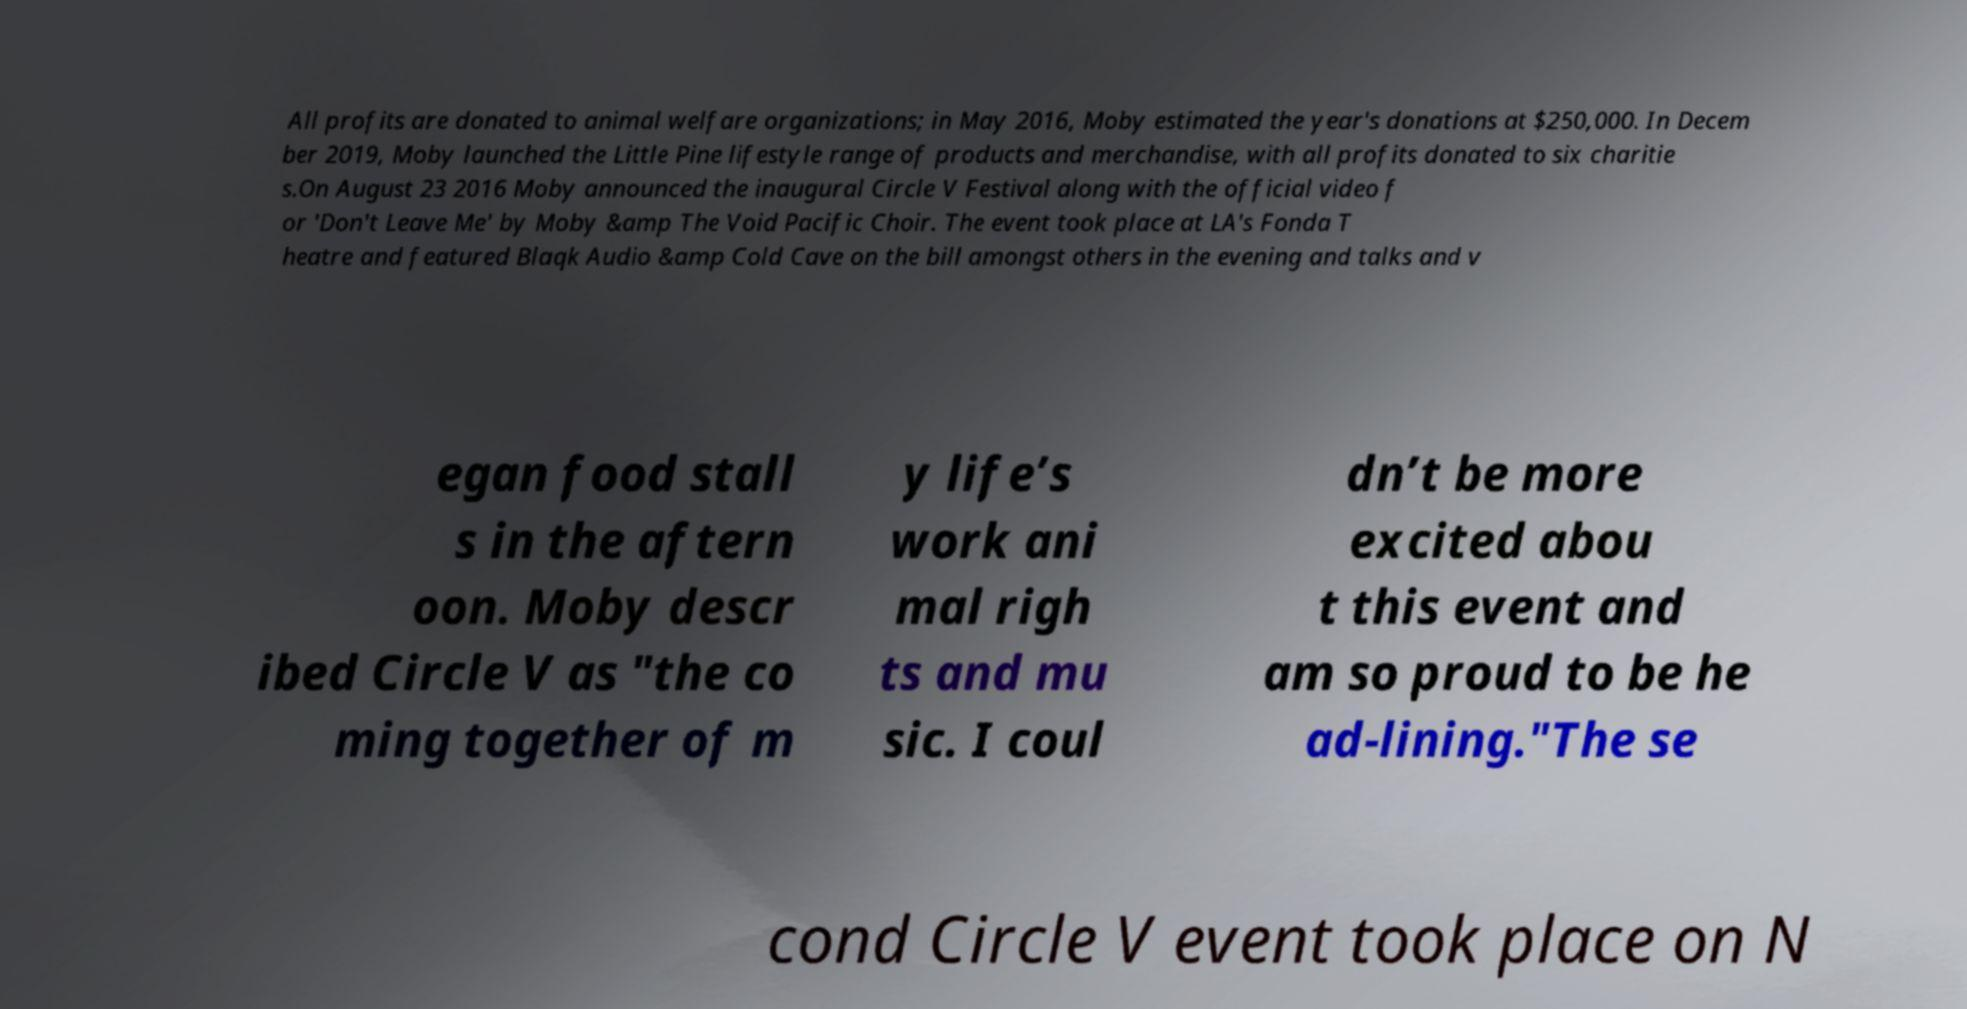What messages or text are displayed in this image? I need them in a readable, typed format. All profits are donated to animal welfare organizations; in May 2016, Moby estimated the year's donations at $250,000. In Decem ber 2019, Moby launched the Little Pine lifestyle range of products and merchandise, with all profits donated to six charitie s.On August 23 2016 Moby announced the inaugural Circle V Festival along with the official video f or 'Don't Leave Me' by Moby &amp The Void Pacific Choir. The event took place at LA's Fonda T heatre and featured Blaqk Audio &amp Cold Cave on the bill amongst others in the evening and talks and v egan food stall s in the aftern oon. Moby descr ibed Circle V as "the co ming together of m y life’s work ani mal righ ts and mu sic. I coul dn’t be more excited abou t this event and am so proud to be he ad-lining."The se cond Circle V event took place on N 